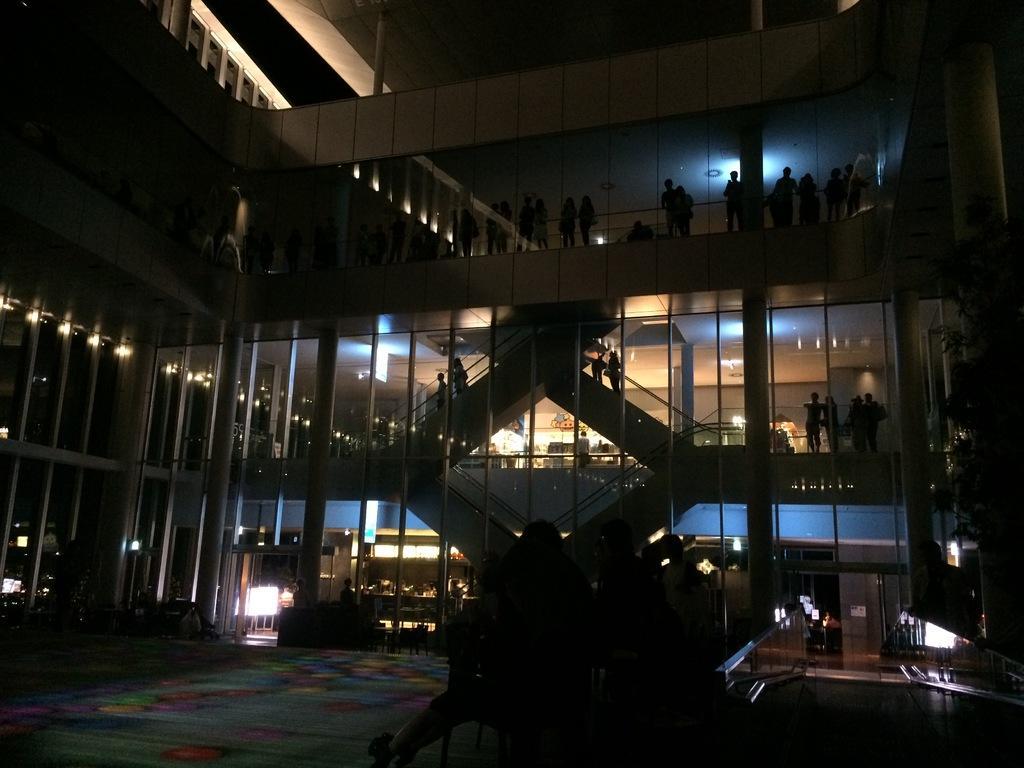In one or two sentences, can you explain what this image depicts? There is a building with pillars, staircases and lights. On the building there are many people. in front of the building also there are people. On the right side there is a tree. 